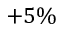<formula> <loc_0><loc_0><loc_500><loc_500>+ 5 \%</formula> 